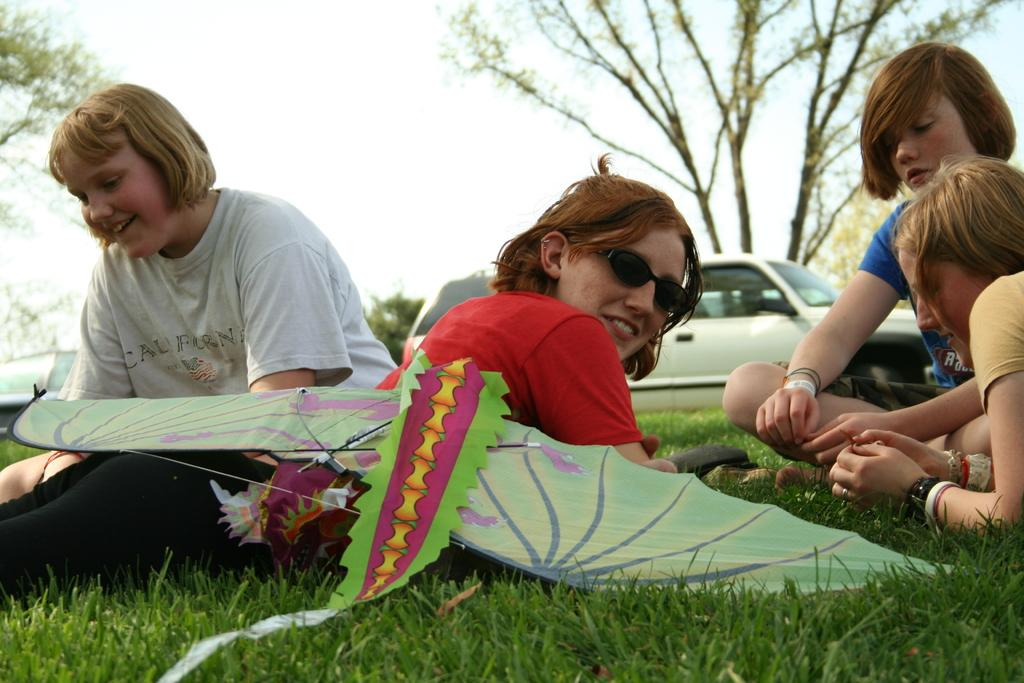What are the people in the image doing? People are sitting on the grass in the image. Can you describe the position of one of the people? There is a person lying down in the image. What color is the t-shirt the person is wearing? The person is wearing a red t-shirt. What type of pants is the person wearing? The person is wearing black pants. What accessory is the person wearing? The person is wearing goggles. What can be seen in the sky in the image? There is a kite in the image. What is visible in the background of the image? There is a car and trees present in the background. How does the butter affect the rainstorm in the image? There is no rainstorm present in the image, so the butter cannot affect it. What type of curtain is hanging from the trees in the image? There are no curtains hanging from the trees in the image; only a car and trees are visible in the background. 